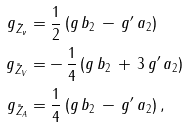Convert formula to latex. <formula><loc_0><loc_0><loc_500><loc_500>g _ { \tilde { Z } _ { \nu } } & = \frac { 1 } { 2 } \, ( g \, b _ { 2 } \, - \, g ^ { \prime } \, a _ { 2 } ) \\ g _ { \tilde { Z } _ { V } } & = - \, \frac { 1 } { 4 } \, ( g \, b _ { 2 } \, + \, 3 \, g ^ { \prime } \, a _ { 2 } ) \\ g _ { \tilde { Z } _ { A } } & = \frac { 1 } { 4 } \, ( g \, b _ { 2 } \, - \, g ^ { \prime } \, a _ { 2 } ) \, ,</formula> 